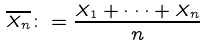Convert formula to latex. <formula><loc_0><loc_0><loc_500><loc_500>\overline { X _ { n } } \colon = \frac { X _ { 1 } + \cdot \cdot \cdot + X _ { n } } { n }</formula> 